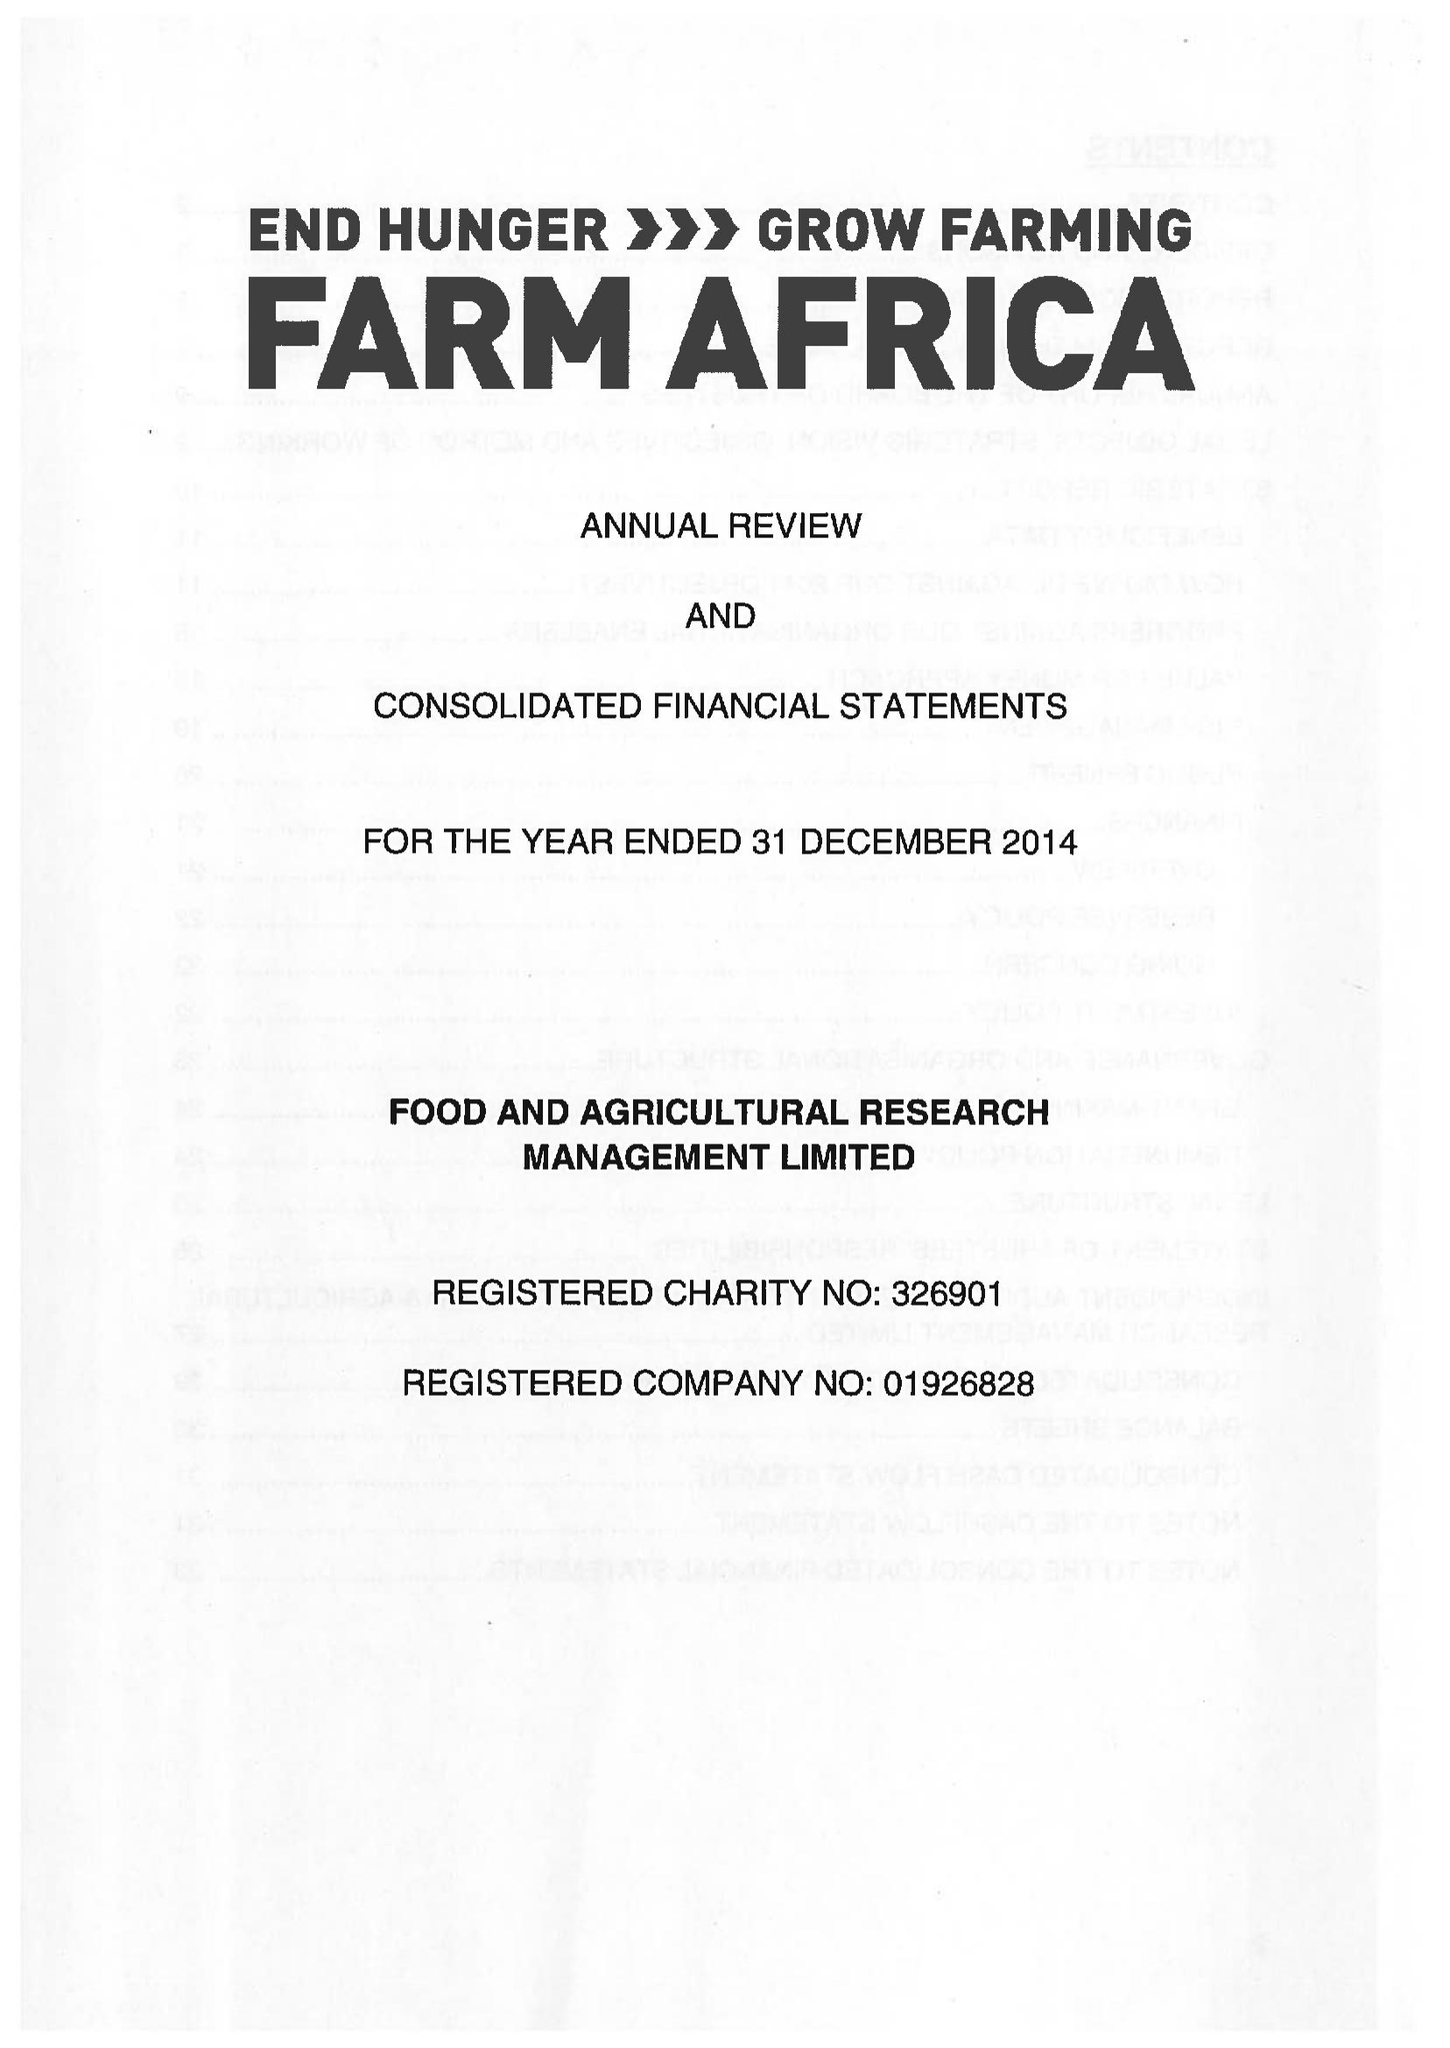What is the value for the address__postcode?
Answer the question using a single word or phrase. EC2Y 5DN 